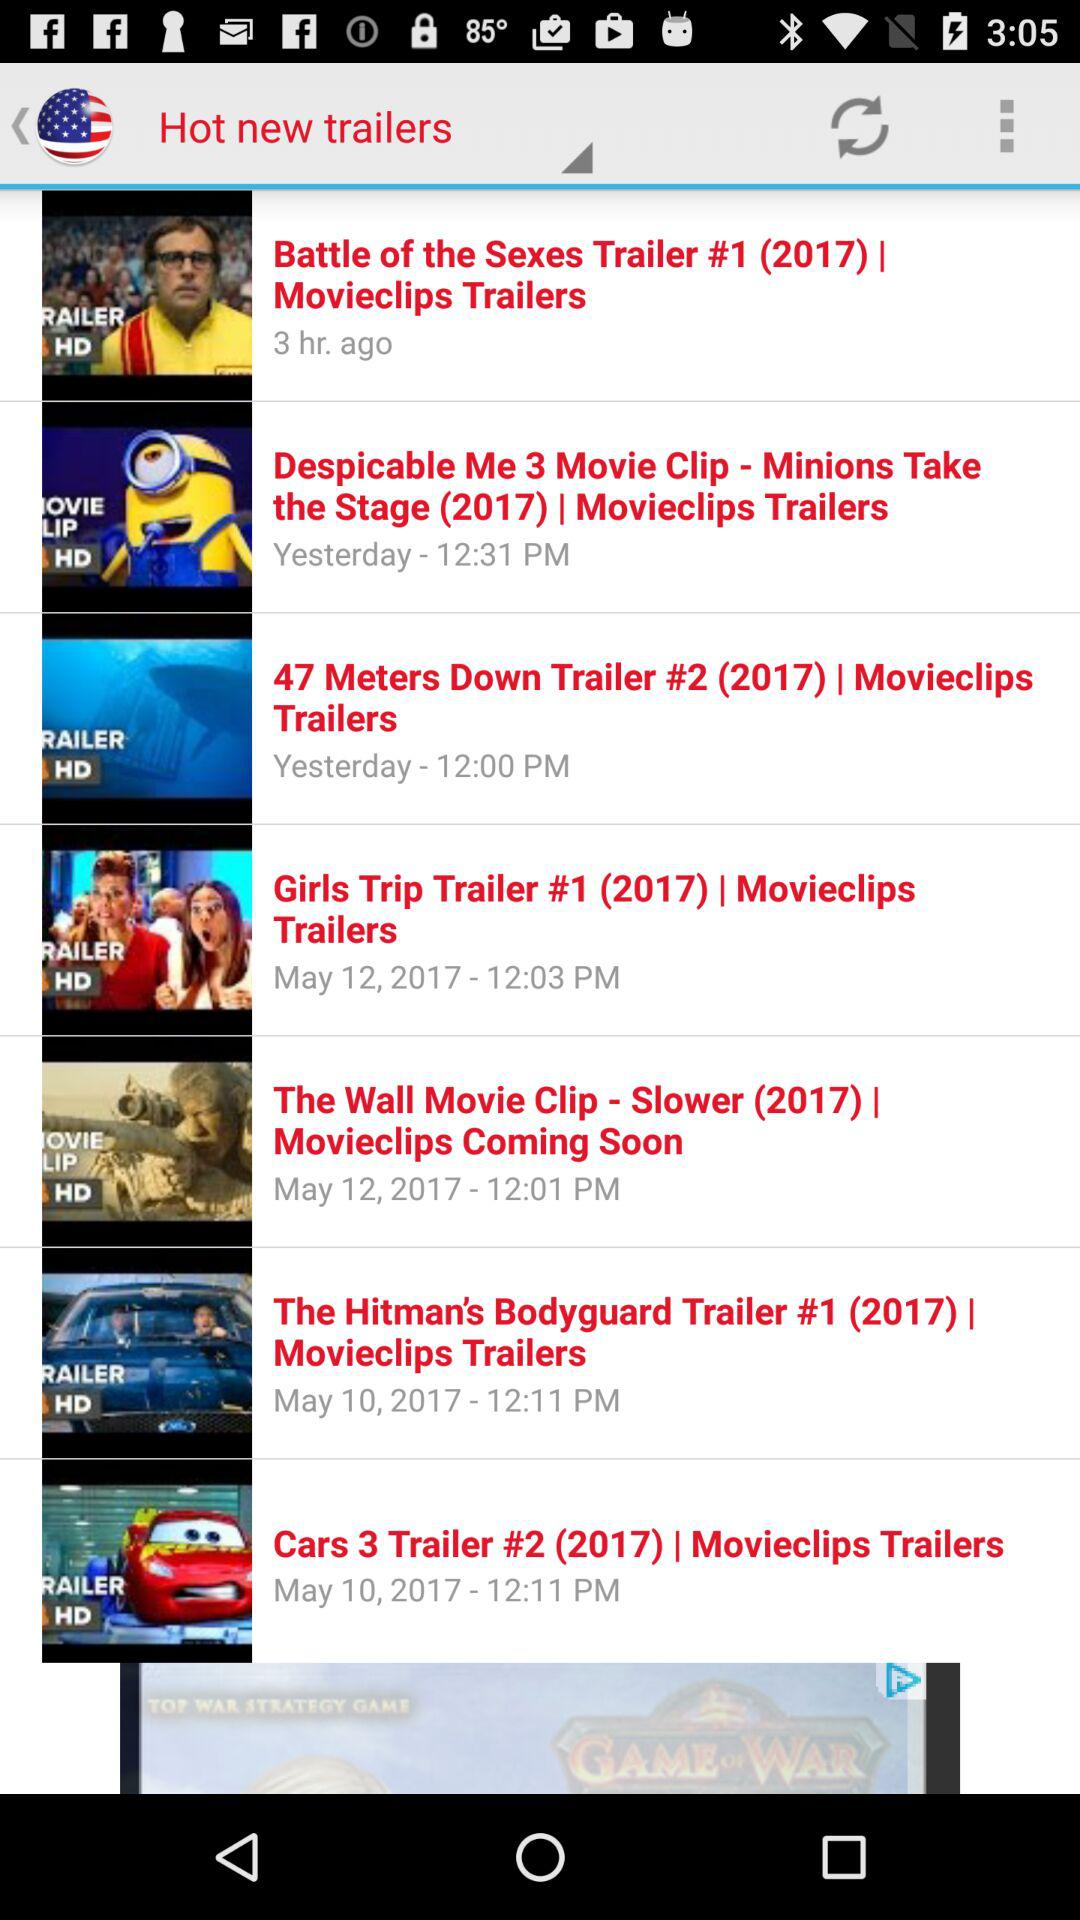What was the year of the "Girls Trip" movie trailer? The year was 2017. 